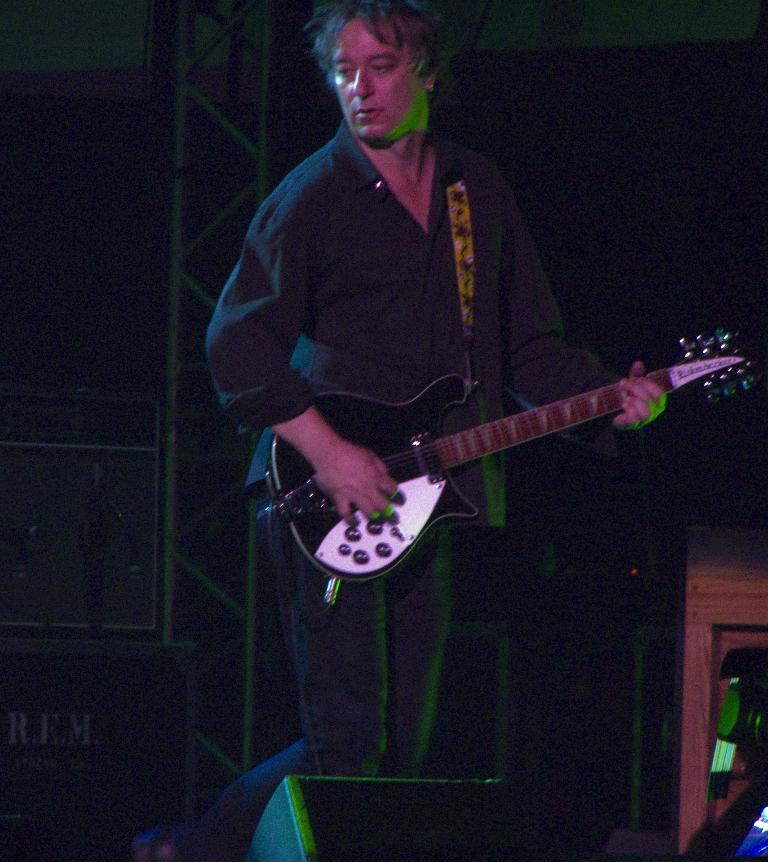Could you give a brief overview of what you see in this image? There is a person holding a guitar and playing. In front of him there is a speaker. In the back there is a stand. 